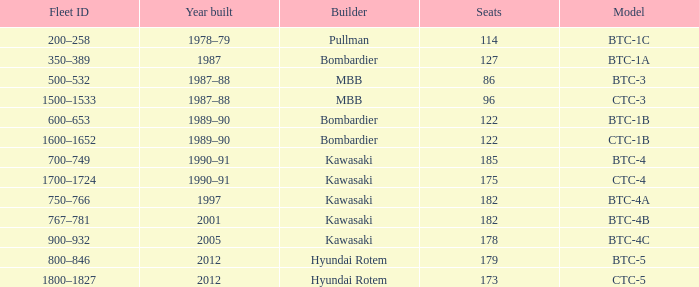In what year was the ctc-3 model built? 1987–88. 